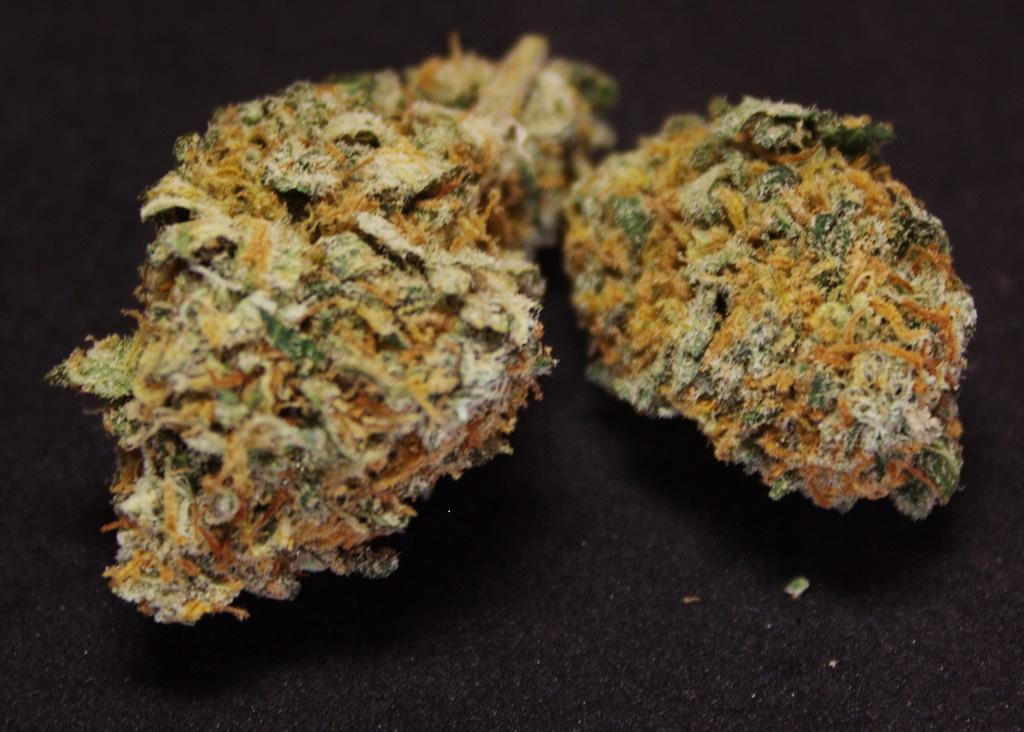What colors are the objects in the image? The objects in the image are in yellow and green colors. What is the surface on which the objects are placed? The objects are placed on a black surface. What color is the background of the image? The background of the image is black. How many potatoes can be seen in the image? There are no potatoes present in the image. 